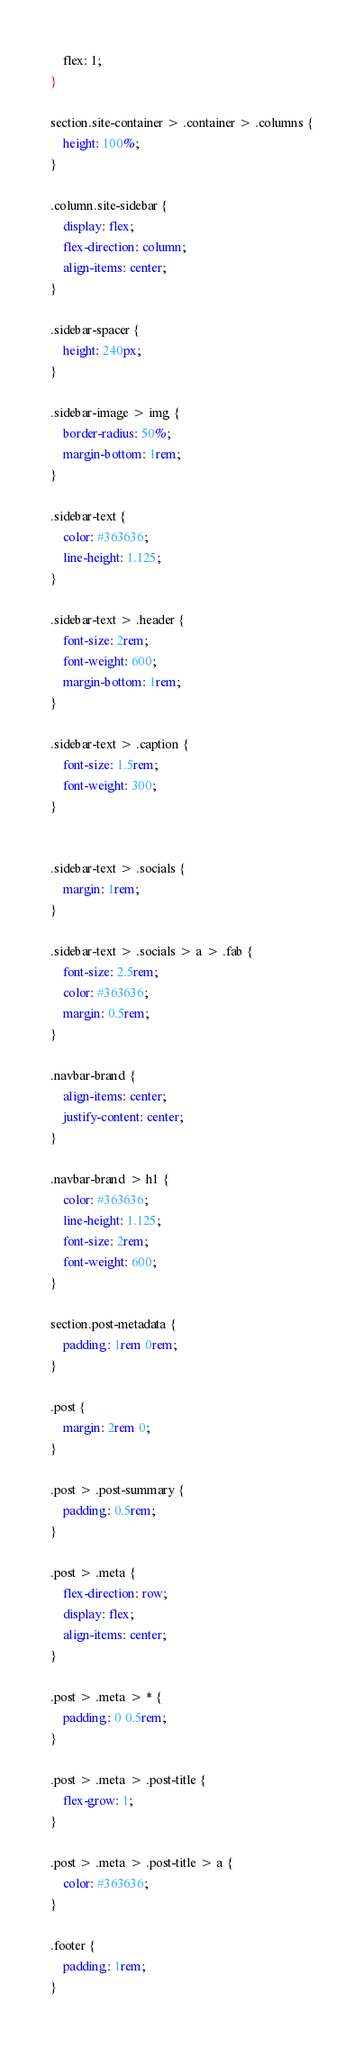<code> <loc_0><loc_0><loc_500><loc_500><_CSS_>    flex: 1;
}

section.site-container > .container > .columns {
    height: 100%;
}

.column.site-sidebar {
    display: flex;
    flex-direction: column;
    align-items: center;
}

.sidebar-spacer {
    height: 240px;
}

.sidebar-image > img {
    border-radius: 50%;
    margin-bottom: 1rem;
}

.sidebar-text {
    color: #363636;
    line-height: 1.125;
}

.sidebar-text > .header {
    font-size: 2rem;
    font-weight: 600;
    margin-bottom: 1rem;
}

.sidebar-text > .caption {
    font-size: 1.5rem;
    font-weight: 300;
}


.sidebar-text > .socials {
    margin: 1rem;
}

.sidebar-text > .socials > a > .fab {
    font-size: 2.5rem;
    color: #363636;
    margin: 0.5rem;
}

.navbar-brand {
    align-items: center;
    justify-content: center;
}

.navbar-brand > h1 {
    color: #363636;
    line-height: 1.125;
    font-size: 2rem;
    font-weight: 600;
}

section.post-metadata {
    padding: 1rem 0rem;
}

.post {
    margin: 2rem 0;
}

.post > .post-summary {
    padding: 0.5rem;
}

.post > .meta {
    flex-direction: row;
    display: flex;
    align-items: center;
}

.post > .meta > * {
    padding: 0 0.5rem;
}

.post > .meta > .post-title {
    flex-grow: 1;
}

.post > .meta > .post-title > a {
    color: #363636;
}

.footer {
    padding: 1rem;
}
</code> 